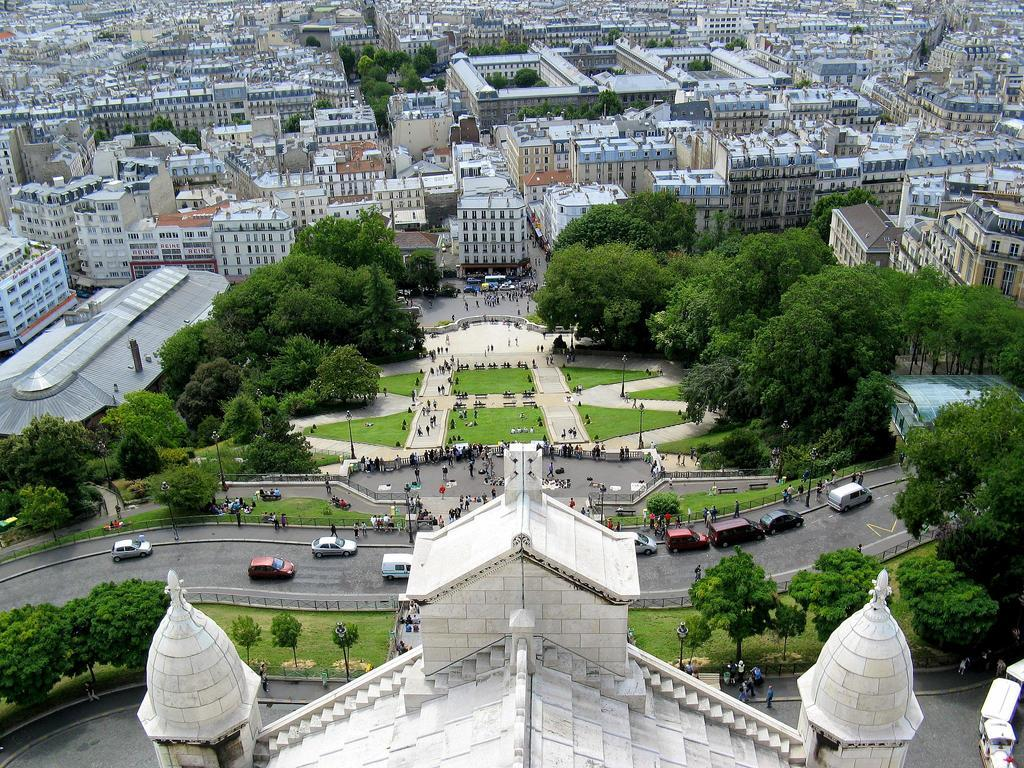What type of structures can be seen in the image? There are buildings in the image. What feature can be observed on the buildings? There are windows visible in the image. What type of natural elements are present in the image? There are trees in the image. What type of man-made objects can be seen in the image? There are poles in the image. Who or what else is present in the image? There are people and vehicles on the road in the image. What type of harmony can be heard in the image? There is no audible sound in the image, so it is not possible to determine if any harmony can be heard. Can you see any blades in the image? There are no blades visible in the image. 